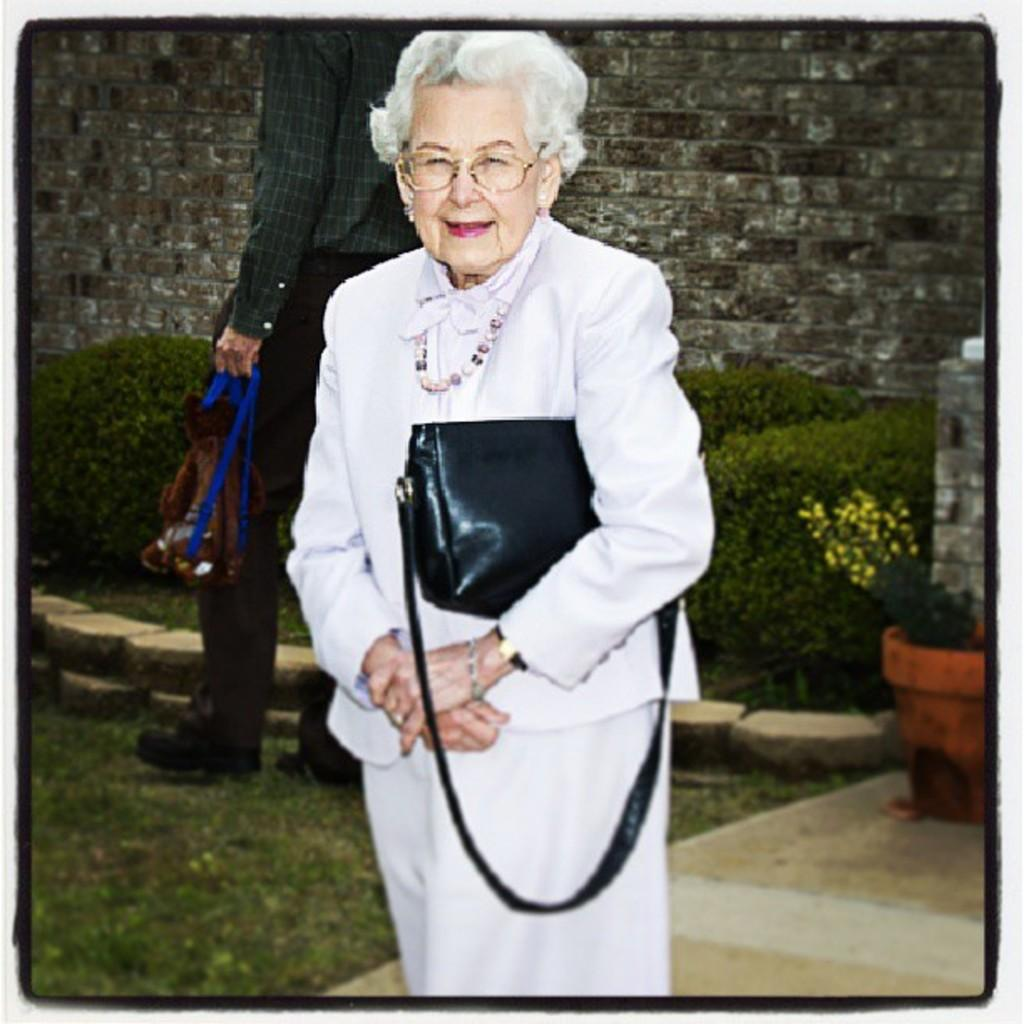What is the woman in the image doing? The woman is standing and holding a bag in the image. What is the woman's facial expression? The woman is smiling. Can you describe the person behind the woman? The person walking behind the woman is also holding a bag. What type of vegetation can be seen in the image? There are plants and flowers in the image. What object can be seen holding the plants and flowers? There is a pot in the image. What is the background of the image? There is a wall in the image. What type of cup is being used to hold the nation in the image? There is no cup or nation present in the image. 